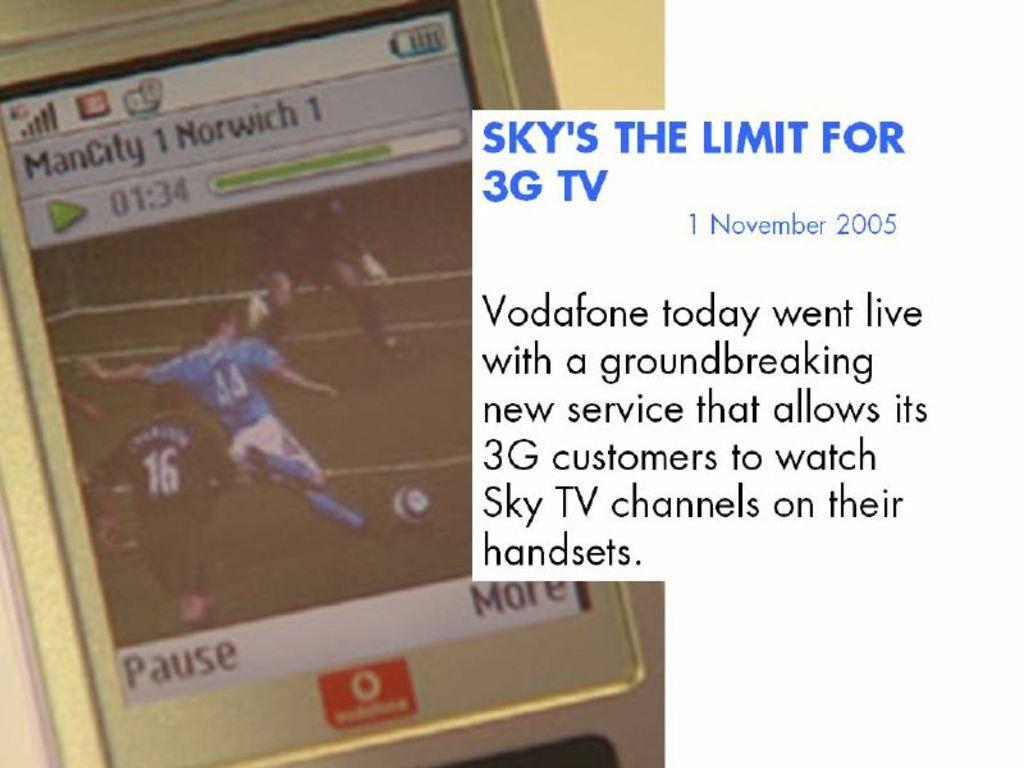<image>
Provide a brief description of the given image. A cell phone with a soccer game between ManCity and Norwich on it's screen. 